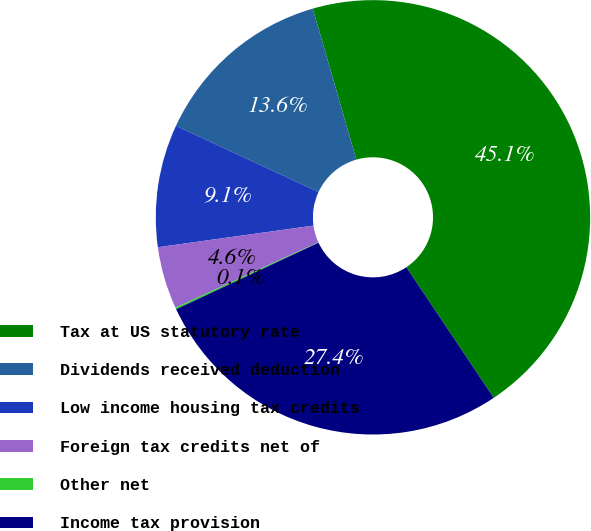Convert chart. <chart><loc_0><loc_0><loc_500><loc_500><pie_chart><fcel>Tax at US statutory rate<fcel>Dividends received deduction<fcel>Low income housing tax credits<fcel>Foreign tax credits net of<fcel>Other net<fcel>Income tax provision<nl><fcel>45.08%<fcel>13.61%<fcel>9.12%<fcel>4.62%<fcel>0.13%<fcel>27.43%<nl></chart> 